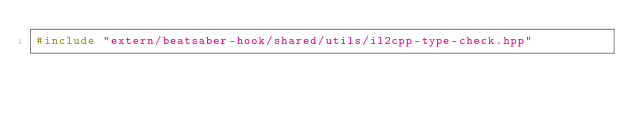<code> <loc_0><loc_0><loc_500><loc_500><_C++_>#include "extern/beatsaber-hook/shared/utils/il2cpp-type-check.hpp"</code> 